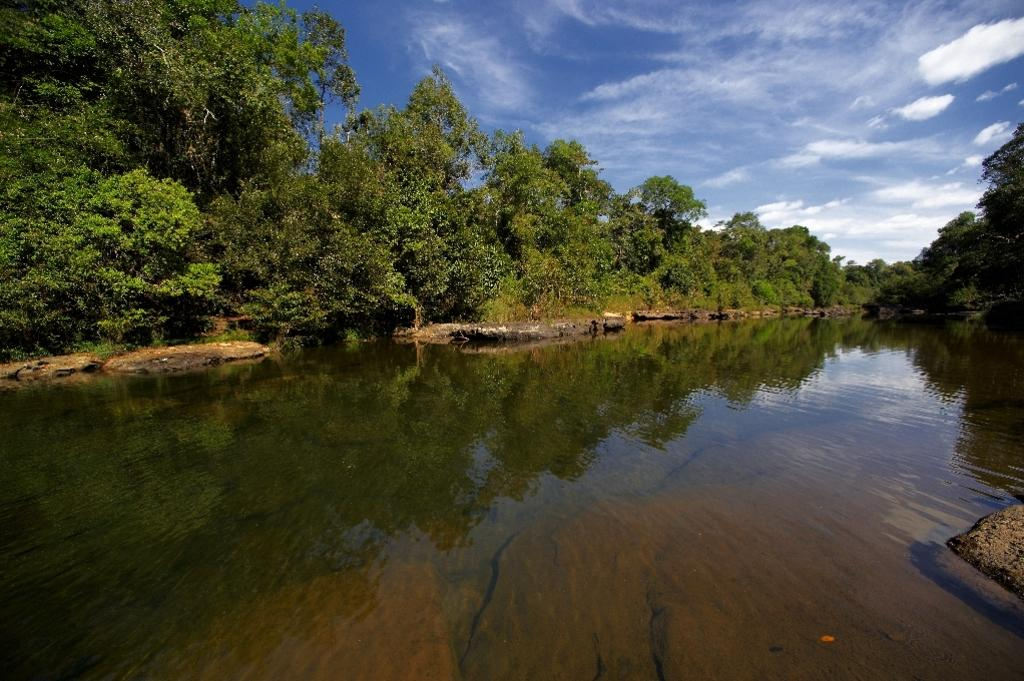What is the primary element in the image? The image consists of water. What can be seen on the left side of the image? There are trees on the left side of the image. What can be seen on the right side of the image? There are trees on the right side of the image. What is visible in the sky at the top of the image? There are clouds in the sky at the top of the image. What is located at the bottom right of the image? There is a rock at the bottom right of the image. What type of approval is being given by the thunder in the image? There is no thunder present in the image, so it is not possible to determine if any approval is being given. 